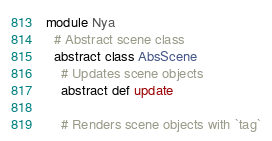Convert code to text. <code><loc_0><loc_0><loc_500><loc_500><_Crystal_>module Nya
  # Abstract scene class
  abstract class AbsScene
    # Updates scene objects
    abstract def update

    # Renders scene objects with `tag`</code> 